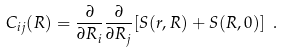Convert formula to latex. <formula><loc_0><loc_0><loc_500><loc_500>C _ { i j } ( { R } ) = \frac { \partial } { \partial R _ { i } } \frac { \partial } { \partial R _ { j } } [ S ( { r } , { R } ) + S ( { R } , 0 ) ] \ .</formula> 